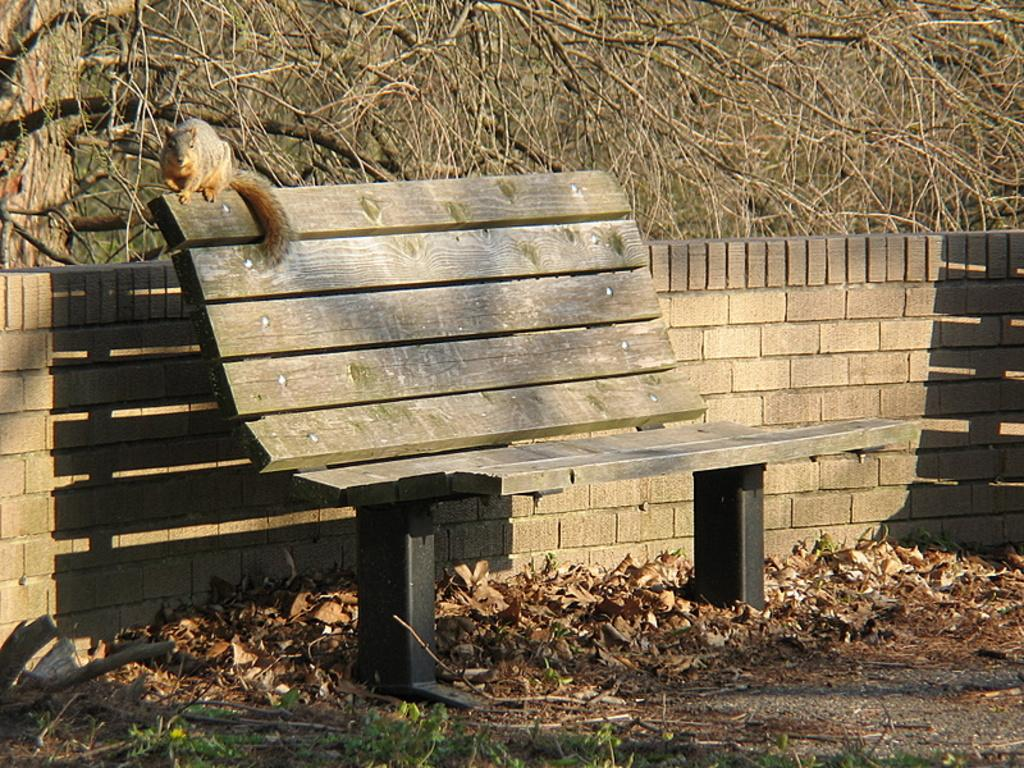What animal is present in the image? There is a squirrel in the image. What is the squirrel doing in the image? The squirrel is sitting on a chair. What can be seen in the background of the image? There are trees visible behind the squirrel. How many legs does the squirrel have in the image? The squirrel has four legs, but this question is irrelevant to the image as it does not focus on any specific detail provided in the facts. 